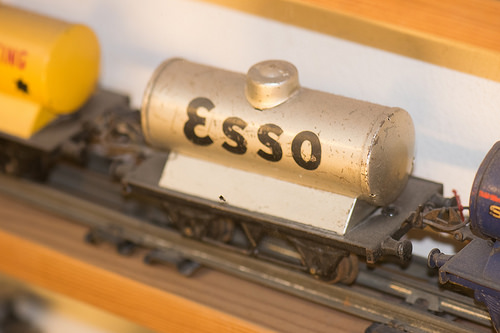<image>
Is the toy train on the track? Yes. Looking at the image, I can see the toy train is positioned on top of the track, with the track providing support. 